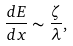Convert formula to latex. <formula><loc_0><loc_0><loc_500><loc_500>\frac { d E } { d x } \sim \frac { \zeta } { \lambda } ,</formula> 